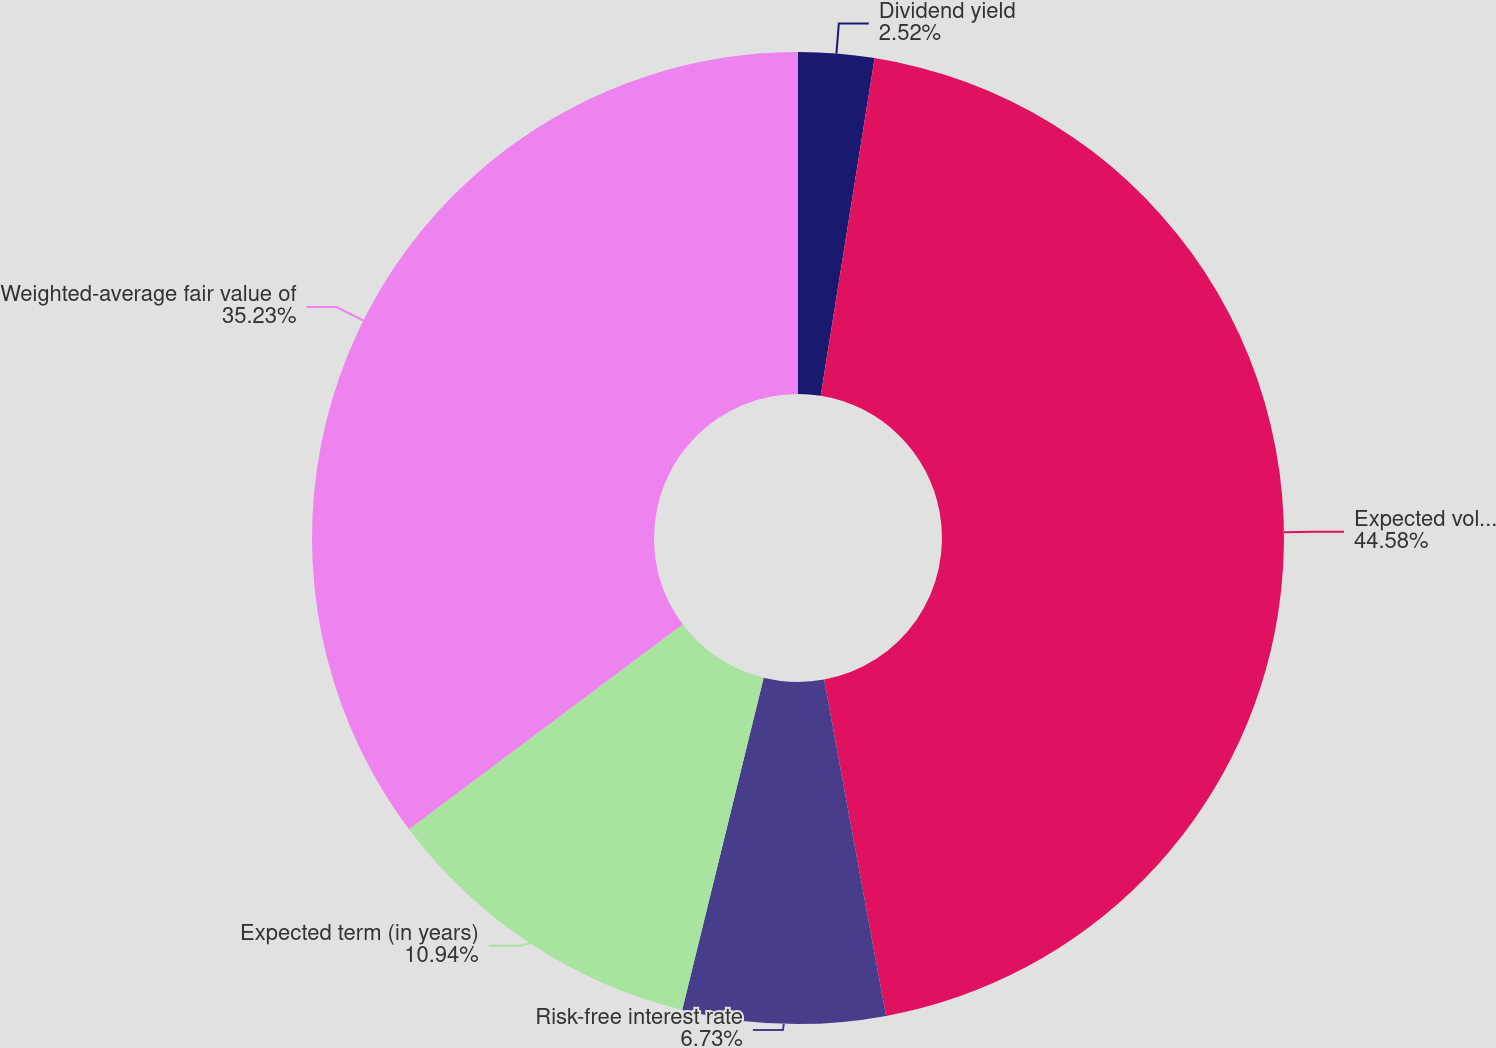Convert chart. <chart><loc_0><loc_0><loc_500><loc_500><pie_chart><fcel>Dividend yield<fcel>Expected volatility<fcel>Risk-free interest rate<fcel>Expected term (in years)<fcel>Weighted-average fair value of<nl><fcel>2.52%<fcel>44.58%<fcel>6.73%<fcel>10.94%<fcel>35.23%<nl></chart> 